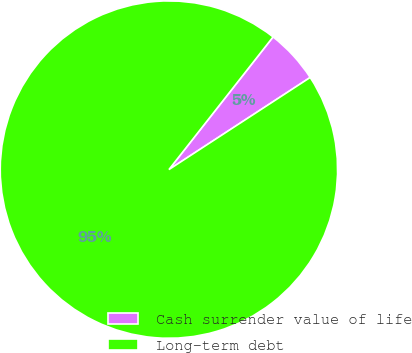Convert chart to OTSL. <chart><loc_0><loc_0><loc_500><loc_500><pie_chart><fcel>Cash surrender value of life<fcel>Long-term debt<nl><fcel>5.21%<fcel>94.79%<nl></chart> 